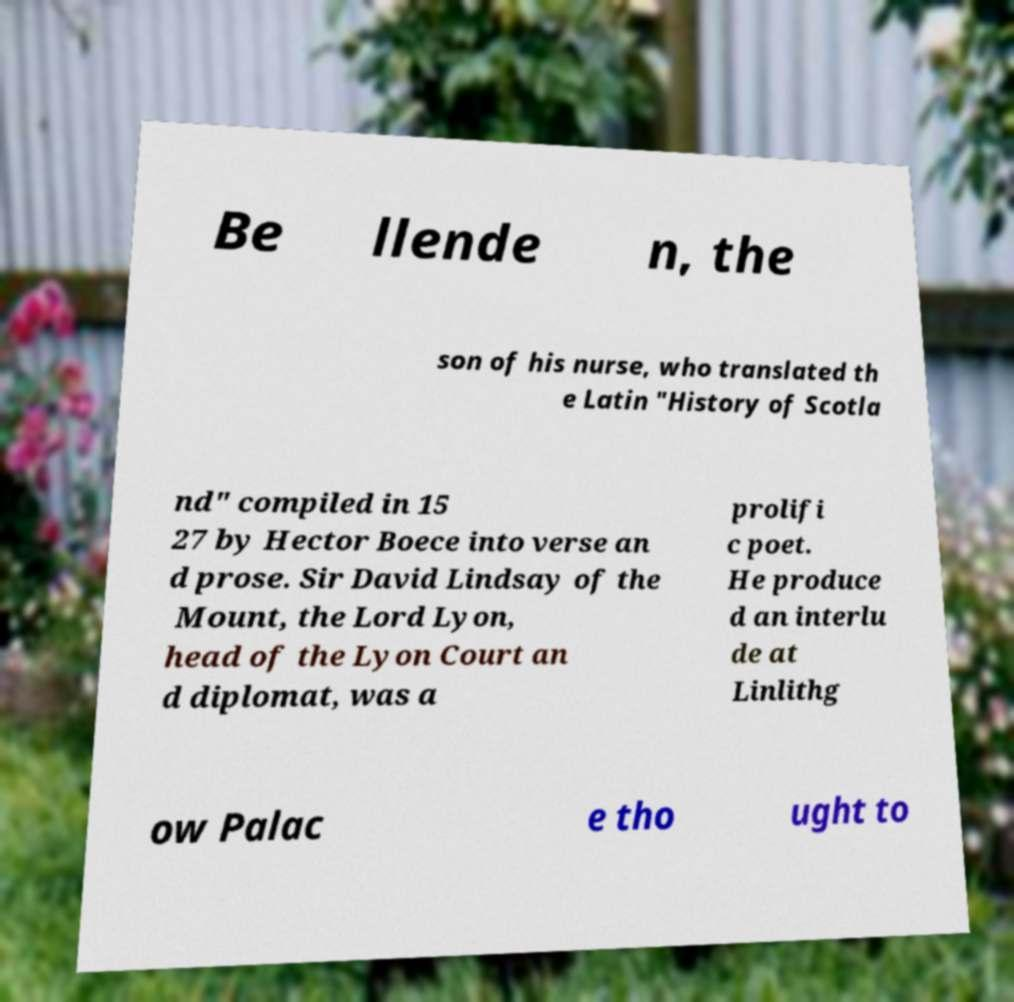Please read and relay the text visible in this image. What does it say? Be llende n, the son of his nurse, who translated th e Latin "History of Scotla nd" compiled in 15 27 by Hector Boece into verse an d prose. Sir David Lindsay of the Mount, the Lord Lyon, head of the Lyon Court an d diplomat, was a prolifi c poet. He produce d an interlu de at Linlithg ow Palac e tho ught to 